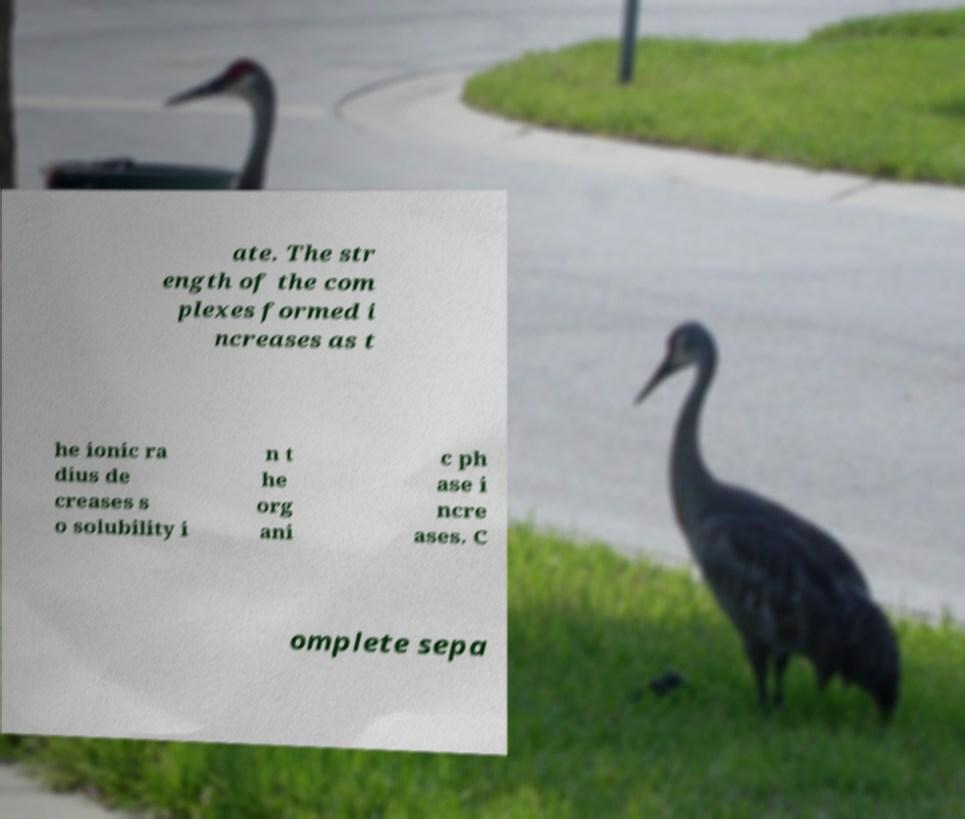There's text embedded in this image that I need extracted. Can you transcribe it verbatim? ate. The str ength of the com plexes formed i ncreases as t he ionic ra dius de creases s o solubility i n t he org ani c ph ase i ncre ases. C omplete sepa 